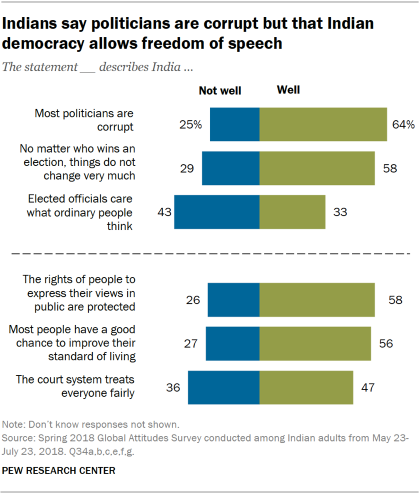Draw attention to some important aspects in this diagram. To determine the result of dividing the larger value by the smaller value, we first calculate the median of the blue and green bars. The final result is an integer value. The color of the bar that represents 25% of the value of the "Most politicians are corrupt" category is blue. 